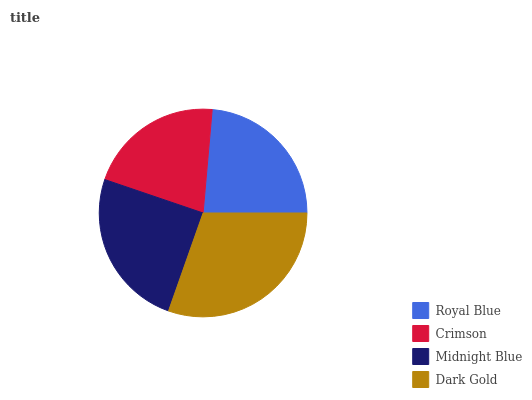Is Crimson the minimum?
Answer yes or no. Yes. Is Dark Gold the maximum?
Answer yes or no. Yes. Is Midnight Blue the minimum?
Answer yes or no. No. Is Midnight Blue the maximum?
Answer yes or no. No. Is Midnight Blue greater than Crimson?
Answer yes or no. Yes. Is Crimson less than Midnight Blue?
Answer yes or no. Yes. Is Crimson greater than Midnight Blue?
Answer yes or no. No. Is Midnight Blue less than Crimson?
Answer yes or no. No. Is Midnight Blue the high median?
Answer yes or no. Yes. Is Royal Blue the low median?
Answer yes or no. Yes. Is Dark Gold the high median?
Answer yes or no. No. Is Dark Gold the low median?
Answer yes or no. No. 